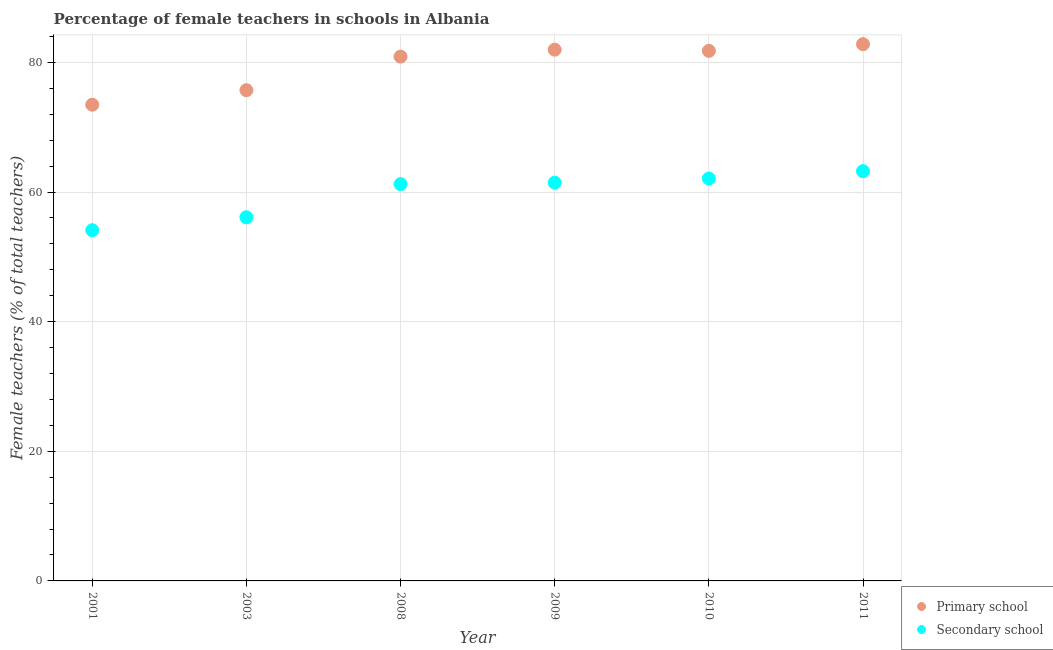How many different coloured dotlines are there?
Make the answer very short. 2. What is the percentage of female teachers in primary schools in 2001?
Provide a succinct answer. 73.47. Across all years, what is the maximum percentage of female teachers in secondary schools?
Your response must be concise. 63.22. Across all years, what is the minimum percentage of female teachers in secondary schools?
Keep it short and to the point. 54.11. What is the total percentage of female teachers in primary schools in the graph?
Your response must be concise. 476.61. What is the difference between the percentage of female teachers in primary schools in 2001 and that in 2008?
Provide a short and direct response. -7.42. What is the difference between the percentage of female teachers in primary schools in 2003 and the percentage of female teachers in secondary schools in 2008?
Offer a terse response. 14.49. What is the average percentage of female teachers in secondary schools per year?
Ensure brevity in your answer.  59.69. In the year 2009, what is the difference between the percentage of female teachers in secondary schools and percentage of female teachers in primary schools?
Provide a succinct answer. -20.52. What is the ratio of the percentage of female teachers in secondary schools in 2003 to that in 2010?
Offer a very short reply. 0.9. What is the difference between the highest and the second highest percentage of female teachers in secondary schools?
Ensure brevity in your answer.  1.13. What is the difference between the highest and the lowest percentage of female teachers in secondary schools?
Offer a very short reply. 9.11. In how many years, is the percentage of female teachers in primary schools greater than the average percentage of female teachers in primary schools taken over all years?
Make the answer very short. 4. Is the sum of the percentage of female teachers in primary schools in 2001 and 2008 greater than the maximum percentage of female teachers in secondary schools across all years?
Your answer should be compact. Yes. Is the percentage of female teachers in primary schools strictly greater than the percentage of female teachers in secondary schools over the years?
Make the answer very short. Yes. Is the percentage of female teachers in secondary schools strictly less than the percentage of female teachers in primary schools over the years?
Your response must be concise. Yes. How many dotlines are there?
Your response must be concise. 2. Are the values on the major ticks of Y-axis written in scientific E-notation?
Your response must be concise. No. How are the legend labels stacked?
Ensure brevity in your answer.  Vertical. What is the title of the graph?
Keep it short and to the point. Percentage of female teachers in schools in Albania. Does "Non-solid fuel" appear as one of the legend labels in the graph?
Provide a short and direct response. No. What is the label or title of the Y-axis?
Provide a succinct answer. Female teachers (% of total teachers). What is the Female teachers (% of total teachers) in Primary school in 2001?
Ensure brevity in your answer.  73.47. What is the Female teachers (% of total teachers) of Secondary school in 2001?
Make the answer very short. 54.11. What is the Female teachers (% of total teachers) in Primary school in 2003?
Ensure brevity in your answer.  75.71. What is the Female teachers (% of total teachers) in Secondary school in 2003?
Make the answer very short. 56.1. What is the Female teachers (% of total teachers) of Primary school in 2008?
Offer a terse response. 80.89. What is the Female teachers (% of total teachers) of Secondary school in 2008?
Your answer should be compact. 61.22. What is the Female teachers (% of total teachers) of Primary school in 2009?
Ensure brevity in your answer.  81.96. What is the Female teachers (% of total teachers) of Secondary school in 2009?
Your answer should be compact. 61.44. What is the Female teachers (% of total teachers) of Primary school in 2010?
Your answer should be very brief. 81.78. What is the Female teachers (% of total teachers) of Secondary school in 2010?
Offer a very short reply. 62.08. What is the Female teachers (% of total teachers) in Primary school in 2011?
Your answer should be very brief. 82.81. What is the Female teachers (% of total teachers) in Secondary school in 2011?
Ensure brevity in your answer.  63.22. Across all years, what is the maximum Female teachers (% of total teachers) in Primary school?
Give a very brief answer. 82.81. Across all years, what is the maximum Female teachers (% of total teachers) of Secondary school?
Provide a succinct answer. 63.22. Across all years, what is the minimum Female teachers (% of total teachers) of Primary school?
Give a very brief answer. 73.47. Across all years, what is the minimum Female teachers (% of total teachers) in Secondary school?
Your answer should be very brief. 54.11. What is the total Female teachers (% of total teachers) of Primary school in the graph?
Ensure brevity in your answer.  476.61. What is the total Female teachers (% of total teachers) in Secondary school in the graph?
Offer a terse response. 358.17. What is the difference between the Female teachers (% of total teachers) of Primary school in 2001 and that in 2003?
Your response must be concise. -2.24. What is the difference between the Female teachers (% of total teachers) of Secondary school in 2001 and that in 2003?
Make the answer very short. -1.99. What is the difference between the Female teachers (% of total teachers) in Primary school in 2001 and that in 2008?
Keep it short and to the point. -7.42. What is the difference between the Female teachers (% of total teachers) in Secondary school in 2001 and that in 2008?
Your answer should be very brief. -7.11. What is the difference between the Female teachers (% of total teachers) in Primary school in 2001 and that in 2009?
Provide a succinct answer. -8.49. What is the difference between the Female teachers (% of total teachers) in Secondary school in 2001 and that in 2009?
Offer a very short reply. -7.33. What is the difference between the Female teachers (% of total teachers) in Primary school in 2001 and that in 2010?
Make the answer very short. -8.31. What is the difference between the Female teachers (% of total teachers) of Secondary school in 2001 and that in 2010?
Your answer should be very brief. -7.98. What is the difference between the Female teachers (% of total teachers) of Primary school in 2001 and that in 2011?
Make the answer very short. -9.34. What is the difference between the Female teachers (% of total teachers) in Secondary school in 2001 and that in 2011?
Make the answer very short. -9.11. What is the difference between the Female teachers (% of total teachers) of Primary school in 2003 and that in 2008?
Provide a succinct answer. -5.18. What is the difference between the Female teachers (% of total teachers) of Secondary school in 2003 and that in 2008?
Keep it short and to the point. -5.12. What is the difference between the Female teachers (% of total teachers) in Primary school in 2003 and that in 2009?
Give a very brief answer. -6.25. What is the difference between the Female teachers (% of total teachers) in Secondary school in 2003 and that in 2009?
Provide a short and direct response. -5.34. What is the difference between the Female teachers (% of total teachers) in Primary school in 2003 and that in 2010?
Provide a succinct answer. -6.07. What is the difference between the Female teachers (% of total teachers) of Secondary school in 2003 and that in 2010?
Your answer should be very brief. -5.98. What is the difference between the Female teachers (% of total teachers) in Primary school in 2003 and that in 2011?
Make the answer very short. -7.1. What is the difference between the Female teachers (% of total teachers) in Secondary school in 2003 and that in 2011?
Your answer should be compact. -7.12. What is the difference between the Female teachers (% of total teachers) in Primary school in 2008 and that in 2009?
Provide a short and direct response. -1.07. What is the difference between the Female teachers (% of total teachers) in Secondary school in 2008 and that in 2009?
Ensure brevity in your answer.  -0.22. What is the difference between the Female teachers (% of total teachers) in Primary school in 2008 and that in 2010?
Offer a terse response. -0.89. What is the difference between the Female teachers (% of total teachers) of Secondary school in 2008 and that in 2010?
Your answer should be very brief. -0.86. What is the difference between the Female teachers (% of total teachers) in Primary school in 2008 and that in 2011?
Your answer should be very brief. -1.92. What is the difference between the Female teachers (% of total teachers) in Secondary school in 2008 and that in 2011?
Offer a terse response. -2. What is the difference between the Female teachers (% of total teachers) in Primary school in 2009 and that in 2010?
Keep it short and to the point. 0.18. What is the difference between the Female teachers (% of total teachers) of Secondary school in 2009 and that in 2010?
Provide a short and direct response. -0.64. What is the difference between the Female teachers (% of total teachers) of Primary school in 2009 and that in 2011?
Keep it short and to the point. -0.85. What is the difference between the Female teachers (% of total teachers) of Secondary school in 2009 and that in 2011?
Provide a short and direct response. -1.78. What is the difference between the Female teachers (% of total teachers) in Primary school in 2010 and that in 2011?
Provide a succinct answer. -1.03. What is the difference between the Female teachers (% of total teachers) in Secondary school in 2010 and that in 2011?
Your answer should be compact. -1.13. What is the difference between the Female teachers (% of total teachers) in Primary school in 2001 and the Female teachers (% of total teachers) in Secondary school in 2003?
Offer a very short reply. 17.37. What is the difference between the Female teachers (% of total teachers) in Primary school in 2001 and the Female teachers (% of total teachers) in Secondary school in 2008?
Your response must be concise. 12.25. What is the difference between the Female teachers (% of total teachers) in Primary school in 2001 and the Female teachers (% of total teachers) in Secondary school in 2009?
Provide a short and direct response. 12.03. What is the difference between the Female teachers (% of total teachers) of Primary school in 2001 and the Female teachers (% of total teachers) of Secondary school in 2010?
Offer a terse response. 11.38. What is the difference between the Female teachers (% of total teachers) in Primary school in 2001 and the Female teachers (% of total teachers) in Secondary school in 2011?
Ensure brevity in your answer.  10.25. What is the difference between the Female teachers (% of total teachers) in Primary school in 2003 and the Female teachers (% of total teachers) in Secondary school in 2008?
Offer a very short reply. 14.49. What is the difference between the Female teachers (% of total teachers) of Primary school in 2003 and the Female teachers (% of total teachers) of Secondary school in 2009?
Provide a succinct answer. 14.27. What is the difference between the Female teachers (% of total teachers) in Primary school in 2003 and the Female teachers (% of total teachers) in Secondary school in 2010?
Keep it short and to the point. 13.63. What is the difference between the Female teachers (% of total teachers) in Primary school in 2003 and the Female teachers (% of total teachers) in Secondary school in 2011?
Make the answer very short. 12.49. What is the difference between the Female teachers (% of total teachers) of Primary school in 2008 and the Female teachers (% of total teachers) of Secondary school in 2009?
Offer a very short reply. 19.45. What is the difference between the Female teachers (% of total teachers) of Primary school in 2008 and the Female teachers (% of total teachers) of Secondary school in 2010?
Your answer should be compact. 18.81. What is the difference between the Female teachers (% of total teachers) in Primary school in 2008 and the Female teachers (% of total teachers) in Secondary school in 2011?
Offer a very short reply. 17.67. What is the difference between the Female teachers (% of total teachers) in Primary school in 2009 and the Female teachers (% of total teachers) in Secondary school in 2010?
Your response must be concise. 19.88. What is the difference between the Female teachers (% of total teachers) in Primary school in 2009 and the Female teachers (% of total teachers) in Secondary school in 2011?
Provide a short and direct response. 18.74. What is the difference between the Female teachers (% of total teachers) of Primary school in 2010 and the Female teachers (% of total teachers) of Secondary school in 2011?
Keep it short and to the point. 18.56. What is the average Female teachers (% of total teachers) of Primary school per year?
Provide a succinct answer. 79.44. What is the average Female teachers (% of total teachers) of Secondary school per year?
Your answer should be very brief. 59.69. In the year 2001, what is the difference between the Female teachers (% of total teachers) in Primary school and Female teachers (% of total teachers) in Secondary school?
Your response must be concise. 19.36. In the year 2003, what is the difference between the Female teachers (% of total teachers) of Primary school and Female teachers (% of total teachers) of Secondary school?
Provide a succinct answer. 19.61. In the year 2008, what is the difference between the Female teachers (% of total teachers) of Primary school and Female teachers (% of total teachers) of Secondary school?
Your response must be concise. 19.67. In the year 2009, what is the difference between the Female teachers (% of total teachers) in Primary school and Female teachers (% of total teachers) in Secondary school?
Provide a succinct answer. 20.52. In the year 2010, what is the difference between the Female teachers (% of total teachers) in Primary school and Female teachers (% of total teachers) in Secondary school?
Offer a terse response. 19.69. In the year 2011, what is the difference between the Female teachers (% of total teachers) of Primary school and Female teachers (% of total teachers) of Secondary school?
Your response must be concise. 19.59. What is the ratio of the Female teachers (% of total teachers) of Primary school in 2001 to that in 2003?
Offer a terse response. 0.97. What is the ratio of the Female teachers (% of total teachers) of Secondary school in 2001 to that in 2003?
Offer a very short reply. 0.96. What is the ratio of the Female teachers (% of total teachers) of Primary school in 2001 to that in 2008?
Offer a terse response. 0.91. What is the ratio of the Female teachers (% of total teachers) in Secondary school in 2001 to that in 2008?
Give a very brief answer. 0.88. What is the ratio of the Female teachers (% of total teachers) in Primary school in 2001 to that in 2009?
Your answer should be very brief. 0.9. What is the ratio of the Female teachers (% of total teachers) in Secondary school in 2001 to that in 2009?
Give a very brief answer. 0.88. What is the ratio of the Female teachers (% of total teachers) of Primary school in 2001 to that in 2010?
Offer a terse response. 0.9. What is the ratio of the Female teachers (% of total teachers) in Secondary school in 2001 to that in 2010?
Make the answer very short. 0.87. What is the ratio of the Female teachers (% of total teachers) in Primary school in 2001 to that in 2011?
Give a very brief answer. 0.89. What is the ratio of the Female teachers (% of total teachers) in Secondary school in 2001 to that in 2011?
Offer a very short reply. 0.86. What is the ratio of the Female teachers (% of total teachers) of Primary school in 2003 to that in 2008?
Give a very brief answer. 0.94. What is the ratio of the Female teachers (% of total teachers) in Secondary school in 2003 to that in 2008?
Ensure brevity in your answer.  0.92. What is the ratio of the Female teachers (% of total teachers) in Primary school in 2003 to that in 2009?
Keep it short and to the point. 0.92. What is the ratio of the Female teachers (% of total teachers) of Secondary school in 2003 to that in 2009?
Give a very brief answer. 0.91. What is the ratio of the Female teachers (% of total teachers) in Primary school in 2003 to that in 2010?
Provide a succinct answer. 0.93. What is the ratio of the Female teachers (% of total teachers) in Secondary school in 2003 to that in 2010?
Provide a succinct answer. 0.9. What is the ratio of the Female teachers (% of total teachers) of Primary school in 2003 to that in 2011?
Provide a short and direct response. 0.91. What is the ratio of the Female teachers (% of total teachers) of Secondary school in 2003 to that in 2011?
Make the answer very short. 0.89. What is the ratio of the Female teachers (% of total teachers) of Secondary school in 2008 to that in 2010?
Keep it short and to the point. 0.99. What is the ratio of the Female teachers (% of total teachers) in Primary school in 2008 to that in 2011?
Offer a terse response. 0.98. What is the ratio of the Female teachers (% of total teachers) in Secondary school in 2008 to that in 2011?
Your response must be concise. 0.97. What is the ratio of the Female teachers (% of total teachers) in Secondary school in 2009 to that in 2011?
Provide a short and direct response. 0.97. What is the ratio of the Female teachers (% of total teachers) in Primary school in 2010 to that in 2011?
Keep it short and to the point. 0.99. What is the ratio of the Female teachers (% of total teachers) in Secondary school in 2010 to that in 2011?
Make the answer very short. 0.98. What is the difference between the highest and the second highest Female teachers (% of total teachers) of Primary school?
Offer a very short reply. 0.85. What is the difference between the highest and the second highest Female teachers (% of total teachers) in Secondary school?
Offer a very short reply. 1.13. What is the difference between the highest and the lowest Female teachers (% of total teachers) of Primary school?
Keep it short and to the point. 9.34. What is the difference between the highest and the lowest Female teachers (% of total teachers) in Secondary school?
Offer a terse response. 9.11. 